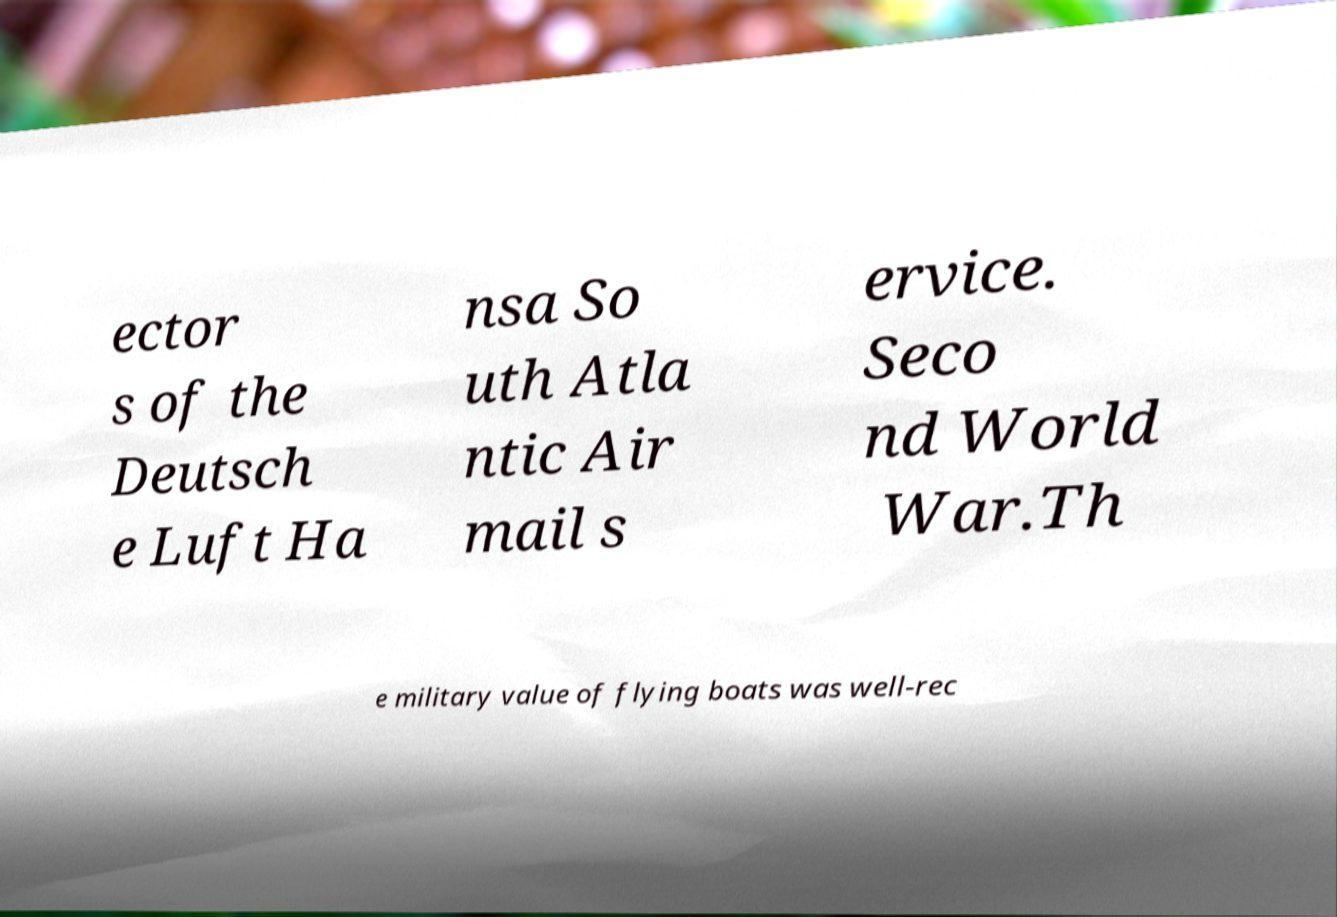For documentation purposes, I need the text within this image transcribed. Could you provide that? ector s of the Deutsch e Luft Ha nsa So uth Atla ntic Air mail s ervice. Seco nd World War.Th e military value of flying boats was well-rec 